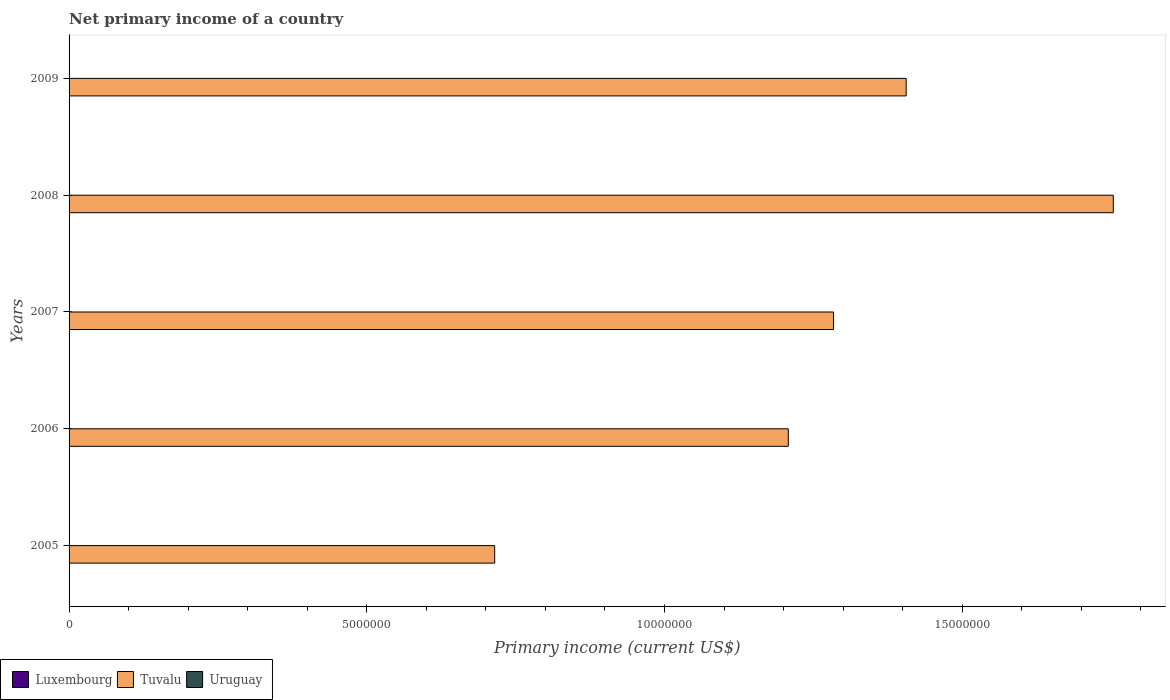How many different coloured bars are there?
Your response must be concise. 1. Are the number of bars per tick equal to the number of legend labels?
Offer a very short reply. No. How many bars are there on the 3rd tick from the bottom?
Your answer should be compact. 1. In how many cases, is the number of bars for a given year not equal to the number of legend labels?
Give a very brief answer. 5. What is the primary income in Tuvalu in 2007?
Your answer should be compact. 1.28e+07. Across all years, what is the maximum primary income in Tuvalu?
Provide a short and direct response. 1.75e+07. Across all years, what is the minimum primary income in Uruguay?
Offer a terse response. 0. In which year was the primary income in Tuvalu maximum?
Provide a short and direct response. 2008. What is the total primary income in Uruguay in the graph?
Your answer should be compact. 0. What is the difference between the primary income in Tuvalu in 2008 and that in 2009?
Your response must be concise. 3.48e+06. What is the average primary income in Luxembourg per year?
Give a very brief answer. 0. In how many years, is the primary income in Luxembourg greater than 3000000 US$?
Offer a very short reply. 0. What is the ratio of the primary income in Tuvalu in 2005 to that in 2008?
Give a very brief answer. 0.41. What is the difference between the highest and the second highest primary income in Tuvalu?
Provide a short and direct response. 3.48e+06. What is the difference between the highest and the lowest primary income in Tuvalu?
Provide a succinct answer. 1.04e+07. Is the sum of the primary income in Tuvalu in 2005 and 2006 greater than the maximum primary income in Luxembourg across all years?
Your answer should be very brief. Yes. Are all the bars in the graph horizontal?
Your answer should be compact. Yes. What is the difference between two consecutive major ticks on the X-axis?
Keep it short and to the point. 5.00e+06. Are the values on the major ticks of X-axis written in scientific E-notation?
Ensure brevity in your answer.  No. Does the graph contain any zero values?
Offer a very short reply. Yes. Where does the legend appear in the graph?
Provide a succinct answer. Bottom left. How many legend labels are there?
Offer a very short reply. 3. How are the legend labels stacked?
Give a very brief answer. Horizontal. What is the title of the graph?
Offer a terse response. Net primary income of a country. Does "Switzerland" appear as one of the legend labels in the graph?
Keep it short and to the point. No. What is the label or title of the X-axis?
Keep it short and to the point. Primary income (current US$). What is the Primary income (current US$) in Tuvalu in 2005?
Offer a terse response. 7.15e+06. What is the Primary income (current US$) in Uruguay in 2005?
Your response must be concise. 0. What is the Primary income (current US$) of Luxembourg in 2006?
Offer a terse response. 0. What is the Primary income (current US$) in Tuvalu in 2006?
Provide a succinct answer. 1.21e+07. What is the Primary income (current US$) in Luxembourg in 2007?
Ensure brevity in your answer.  0. What is the Primary income (current US$) of Tuvalu in 2007?
Provide a short and direct response. 1.28e+07. What is the Primary income (current US$) of Luxembourg in 2008?
Your answer should be compact. 0. What is the Primary income (current US$) in Tuvalu in 2008?
Offer a terse response. 1.75e+07. What is the Primary income (current US$) in Tuvalu in 2009?
Provide a short and direct response. 1.41e+07. What is the Primary income (current US$) of Uruguay in 2009?
Your answer should be compact. 0. Across all years, what is the maximum Primary income (current US$) in Tuvalu?
Your answer should be very brief. 1.75e+07. Across all years, what is the minimum Primary income (current US$) in Tuvalu?
Offer a very short reply. 7.15e+06. What is the total Primary income (current US$) in Tuvalu in the graph?
Provide a short and direct response. 6.37e+07. What is the difference between the Primary income (current US$) of Tuvalu in 2005 and that in 2006?
Offer a terse response. -4.93e+06. What is the difference between the Primary income (current US$) of Tuvalu in 2005 and that in 2007?
Your answer should be compact. -5.69e+06. What is the difference between the Primary income (current US$) in Tuvalu in 2005 and that in 2008?
Provide a short and direct response. -1.04e+07. What is the difference between the Primary income (current US$) in Tuvalu in 2005 and that in 2009?
Provide a short and direct response. -6.91e+06. What is the difference between the Primary income (current US$) in Tuvalu in 2006 and that in 2007?
Your answer should be compact. -7.59e+05. What is the difference between the Primary income (current US$) in Tuvalu in 2006 and that in 2008?
Provide a short and direct response. -5.46e+06. What is the difference between the Primary income (current US$) of Tuvalu in 2006 and that in 2009?
Provide a succinct answer. -1.98e+06. What is the difference between the Primary income (current US$) of Tuvalu in 2007 and that in 2008?
Give a very brief answer. -4.70e+06. What is the difference between the Primary income (current US$) of Tuvalu in 2007 and that in 2009?
Your answer should be very brief. -1.22e+06. What is the difference between the Primary income (current US$) in Tuvalu in 2008 and that in 2009?
Your answer should be very brief. 3.48e+06. What is the average Primary income (current US$) of Luxembourg per year?
Make the answer very short. 0. What is the average Primary income (current US$) in Tuvalu per year?
Offer a terse response. 1.27e+07. What is the average Primary income (current US$) of Uruguay per year?
Your answer should be compact. 0. What is the ratio of the Primary income (current US$) in Tuvalu in 2005 to that in 2006?
Your response must be concise. 0.59. What is the ratio of the Primary income (current US$) of Tuvalu in 2005 to that in 2007?
Your response must be concise. 0.56. What is the ratio of the Primary income (current US$) of Tuvalu in 2005 to that in 2008?
Keep it short and to the point. 0.41. What is the ratio of the Primary income (current US$) of Tuvalu in 2005 to that in 2009?
Offer a very short reply. 0.51. What is the ratio of the Primary income (current US$) in Tuvalu in 2006 to that in 2007?
Provide a succinct answer. 0.94. What is the ratio of the Primary income (current US$) in Tuvalu in 2006 to that in 2008?
Provide a succinct answer. 0.69. What is the ratio of the Primary income (current US$) in Tuvalu in 2006 to that in 2009?
Provide a short and direct response. 0.86. What is the ratio of the Primary income (current US$) in Tuvalu in 2007 to that in 2008?
Offer a terse response. 0.73. What is the ratio of the Primary income (current US$) in Tuvalu in 2007 to that in 2009?
Ensure brevity in your answer.  0.91. What is the ratio of the Primary income (current US$) of Tuvalu in 2008 to that in 2009?
Offer a very short reply. 1.25. What is the difference between the highest and the second highest Primary income (current US$) in Tuvalu?
Your answer should be compact. 3.48e+06. What is the difference between the highest and the lowest Primary income (current US$) of Tuvalu?
Your answer should be very brief. 1.04e+07. 